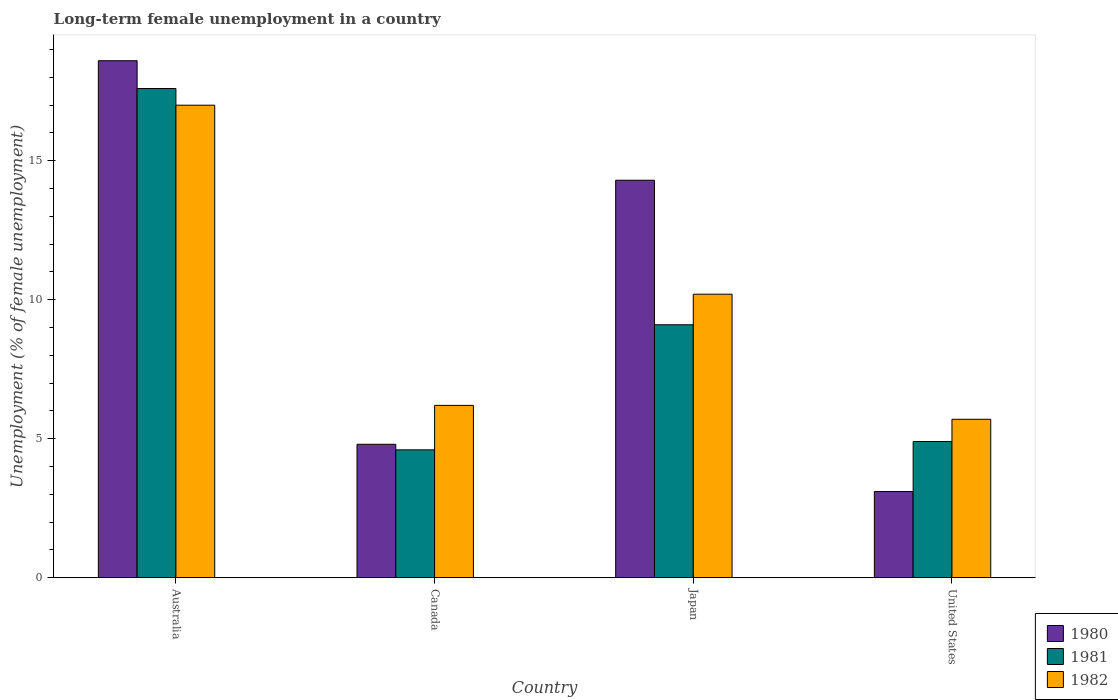Are the number of bars per tick equal to the number of legend labels?
Your answer should be compact. Yes. How many bars are there on the 2nd tick from the left?
Give a very brief answer. 3. What is the label of the 4th group of bars from the left?
Ensure brevity in your answer.  United States. In how many cases, is the number of bars for a given country not equal to the number of legend labels?
Provide a short and direct response. 0. What is the percentage of long-term unemployed female population in 1982 in Japan?
Offer a terse response. 10.2. Across all countries, what is the maximum percentage of long-term unemployed female population in 1981?
Your answer should be very brief. 17.6. Across all countries, what is the minimum percentage of long-term unemployed female population in 1981?
Give a very brief answer. 4.6. In which country was the percentage of long-term unemployed female population in 1981 minimum?
Offer a terse response. Canada. What is the total percentage of long-term unemployed female population in 1981 in the graph?
Your answer should be compact. 36.2. What is the difference between the percentage of long-term unemployed female population in 1981 in Canada and that in United States?
Ensure brevity in your answer.  -0.3. What is the difference between the percentage of long-term unemployed female population in 1980 in Australia and the percentage of long-term unemployed female population in 1981 in Japan?
Give a very brief answer. 9.5. What is the average percentage of long-term unemployed female population in 1982 per country?
Your response must be concise. 9.77. What is the difference between the percentage of long-term unemployed female population of/in 1980 and percentage of long-term unemployed female population of/in 1981 in Japan?
Your answer should be compact. 5.2. In how many countries, is the percentage of long-term unemployed female population in 1982 greater than 2 %?
Your answer should be very brief. 4. What is the ratio of the percentage of long-term unemployed female population in 1982 in Australia to that in Japan?
Ensure brevity in your answer.  1.67. What is the difference between the highest and the second highest percentage of long-term unemployed female population in 1981?
Your answer should be very brief. 12.7. What is the difference between the highest and the lowest percentage of long-term unemployed female population in 1982?
Offer a terse response. 11.3. Is the sum of the percentage of long-term unemployed female population in 1980 in Australia and United States greater than the maximum percentage of long-term unemployed female population in 1982 across all countries?
Your answer should be compact. Yes. What does the 1st bar from the left in United States represents?
Keep it short and to the point. 1980. How many bars are there?
Make the answer very short. 12. What is the difference between two consecutive major ticks on the Y-axis?
Offer a terse response. 5. Are the values on the major ticks of Y-axis written in scientific E-notation?
Provide a short and direct response. No. What is the title of the graph?
Offer a terse response. Long-term female unemployment in a country. Does "1983" appear as one of the legend labels in the graph?
Offer a very short reply. No. What is the label or title of the Y-axis?
Offer a very short reply. Unemployment (% of female unemployment). What is the Unemployment (% of female unemployment) of 1980 in Australia?
Make the answer very short. 18.6. What is the Unemployment (% of female unemployment) of 1981 in Australia?
Ensure brevity in your answer.  17.6. What is the Unemployment (% of female unemployment) of 1982 in Australia?
Provide a short and direct response. 17. What is the Unemployment (% of female unemployment) in 1980 in Canada?
Your answer should be very brief. 4.8. What is the Unemployment (% of female unemployment) of 1981 in Canada?
Your answer should be compact. 4.6. What is the Unemployment (% of female unemployment) of 1982 in Canada?
Your answer should be compact. 6.2. What is the Unemployment (% of female unemployment) of 1980 in Japan?
Make the answer very short. 14.3. What is the Unemployment (% of female unemployment) of 1981 in Japan?
Keep it short and to the point. 9.1. What is the Unemployment (% of female unemployment) in 1982 in Japan?
Offer a terse response. 10.2. What is the Unemployment (% of female unemployment) in 1980 in United States?
Keep it short and to the point. 3.1. What is the Unemployment (% of female unemployment) of 1981 in United States?
Your answer should be compact. 4.9. What is the Unemployment (% of female unemployment) in 1982 in United States?
Ensure brevity in your answer.  5.7. Across all countries, what is the maximum Unemployment (% of female unemployment) in 1980?
Provide a succinct answer. 18.6. Across all countries, what is the maximum Unemployment (% of female unemployment) of 1981?
Offer a terse response. 17.6. Across all countries, what is the minimum Unemployment (% of female unemployment) in 1980?
Keep it short and to the point. 3.1. Across all countries, what is the minimum Unemployment (% of female unemployment) in 1981?
Offer a terse response. 4.6. Across all countries, what is the minimum Unemployment (% of female unemployment) in 1982?
Provide a short and direct response. 5.7. What is the total Unemployment (% of female unemployment) in 1980 in the graph?
Give a very brief answer. 40.8. What is the total Unemployment (% of female unemployment) of 1981 in the graph?
Provide a succinct answer. 36.2. What is the total Unemployment (% of female unemployment) of 1982 in the graph?
Your response must be concise. 39.1. What is the difference between the Unemployment (% of female unemployment) of 1980 in Australia and that in Canada?
Give a very brief answer. 13.8. What is the difference between the Unemployment (% of female unemployment) in 1981 in Australia and that in Japan?
Keep it short and to the point. 8.5. What is the difference between the Unemployment (% of female unemployment) in 1982 in Australia and that in United States?
Give a very brief answer. 11.3. What is the difference between the Unemployment (% of female unemployment) in 1980 in Canada and that in Japan?
Offer a very short reply. -9.5. What is the difference between the Unemployment (% of female unemployment) of 1980 in Canada and that in United States?
Offer a terse response. 1.7. What is the difference between the Unemployment (% of female unemployment) in 1981 in Canada and that in United States?
Offer a very short reply. -0.3. What is the difference between the Unemployment (% of female unemployment) of 1982 in Canada and that in United States?
Offer a very short reply. 0.5. What is the difference between the Unemployment (% of female unemployment) of 1980 in Japan and that in United States?
Offer a terse response. 11.2. What is the difference between the Unemployment (% of female unemployment) of 1981 in Japan and that in United States?
Make the answer very short. 4.2. What is the difference between the Unemployment (% of female unemployment) in 1982 in Japan and that in United States?
Keep it short and to the point. 4.5. What is the difference between the Unemployment (% of female unemployment) in 1980 in Australia and the Unemployment (% of female unemployment) in 1981 in Canada?
Your response must be concise. 14. What is the difference between the Unemployment (% of female unemployment) of 1981 in Australia and the Unemployment (% of female unemployment) of 1982 in Canada?
Your answer should be compact. 11.4. What is the difference between the Unemployment (% of female unemployment) of 1980 in Australia and the Unemployment (% of female unemployment) of 1981 in Japan?
Your answer should be compact. 9.5. What is the difference between the Unemployment (% of female unemployment) of 1980 in Australia and the Unemployment (% of female unemployment) of 1981 in United States?
Offer a terse response. 13.7. What is the difference between the Unemployment (% of female unemployment) in 1980 in Canada and the Unemployment (% of female unemployment) in 1981 in Japan?
Ensure brevity in your answer.  -4.3. What is the difference between the Unemployment (% of female unemployment) in 1981 in Canada and the Unemployment (% of female unemployment) in 1982 in Japan?
Provide a succinct answer. -5.6. What is the difference between the Unemployment (% of female unemployment) of 1980 in Canada and the Unemployment (% of female unemployment) of 1981 in United States?
Your answer should be compact. -0.1. What is the difference between the Unemployment (% of female unemployment) of 1980 in Canada and the Unemployment (% of female unemployment) of 1982 in United States?
Your answer should be compact. -0.9. What is the difference between the Unemployment (% of female unemployment) of 1980 in Japan and the Unemployment (% of female unemployment) of 1981 in United States?
Provide a succinct answer. 9.4. What is the average Unemployment (% of female unemployment) of 1981 per country?
Your answer should be very brief. 9.05. What is the average Unemployment (% of female unemployment) of 1982 per country?
Your answer should be compact. 9.78. What is the difference between the Unemployment (% of female unemployment) of 1980 and Unemployment (% of female unemployment) of 1981 in Canada?
Give a very brief answer. 0.2. What is the difference between the Unemployment (% of female unemployment) in 1980 and Unemployment (% of female unemployment) in 1982 in Canada?
Your response must be concise. -1.4. What is the difference between the Unemployment (% of female unemployment) in 1980 and Unemployment (% of female unemployment) in 1982 in Japan?
Make the answer very short. 4.1. What is the difference between the Unemployment (% of female unemployment) of 1980 and Unemployment (% of female unemployment) of 1981 in United States?
Your answer should be compact. -1.8. What is the difference between the Unemployment (% of female unemployment) of 1981 and Unemployment (% of female unemployment) of 1982 in United States?
Offer a terse response. -0.8. What is the ratio of the Unemployment (% of female unemployment) of 1980 in Australia to that in Canada?
Your answer should be compact. 3.88. What is the ratio of the Unemployment (% of female unemployment) in 1981 in Australia to that in Canada?
Your answer should be very brief. 3.83. What is the ratio of the Unemployment (% of female unemployment) of 1982 in Australia to that in Canada?
Offer a very short reply. 2.74. What is the ratio of the Unemployment (% of female unemployment) of 1980 in Australia to that in Japan?
Keep it short and to the point. 1.3. What is the ratio of the Unemployment (% of female unemployment) of 1981 in Australia to that in Japan?
Provide a succinct answer. 1.93. What is the ratio of the Unemployment (% of female unemployment) in 1981 in Australia to that in United States?
Give a very brief answer. 3.59. What is the ratio of the Unemployment (% of female unemployment) of 1982 in Australia to that in United States?
Provide a succinct answer. 2.98. What is the ratio of the Unemployment (% of female unemployment) in 1980 in Canada to that in Japan?
Offer a terse response. 0.34. What is the ratio of the Unemployment (% of female unemployment) of 1981 in Canada to that in Japan?
Ensure brevity in your answer.  0.51. What is the ratio of the Unemployment (% of female unemployment) of 1982 in Canada to that in Japan?
Give a very brief answer. 0.61. What is the ratio of the Unemployment (% of female unemployment) in 1980 in Canada to that in United States?
Give a very brief answer. 1.55. What is the ratio of the Unemployment (% of female unemployment) of 1981 in Canada to that in United States?
Give a very brief answer. 0.94. What is the ratio of the Unemployment (% of female unemployment) in 1982 in Canada to that in United States?
Keep it short and to the point. 1.09. What is the ratio of the Unemployment (% of female unemployment) of 1980 in Japan to that in United States?
Offer a terse response. 4.61. What is the ratio of the Unemployment (% of female unemployment) in 1981 in Japan to that in United States?
Provide a succinct answer. 1.86. What is the ratio of the Unemployment (% of female unemployment) of 1982 in Japan to that in United States?
Ensure brevity in your answer.  1.79. 